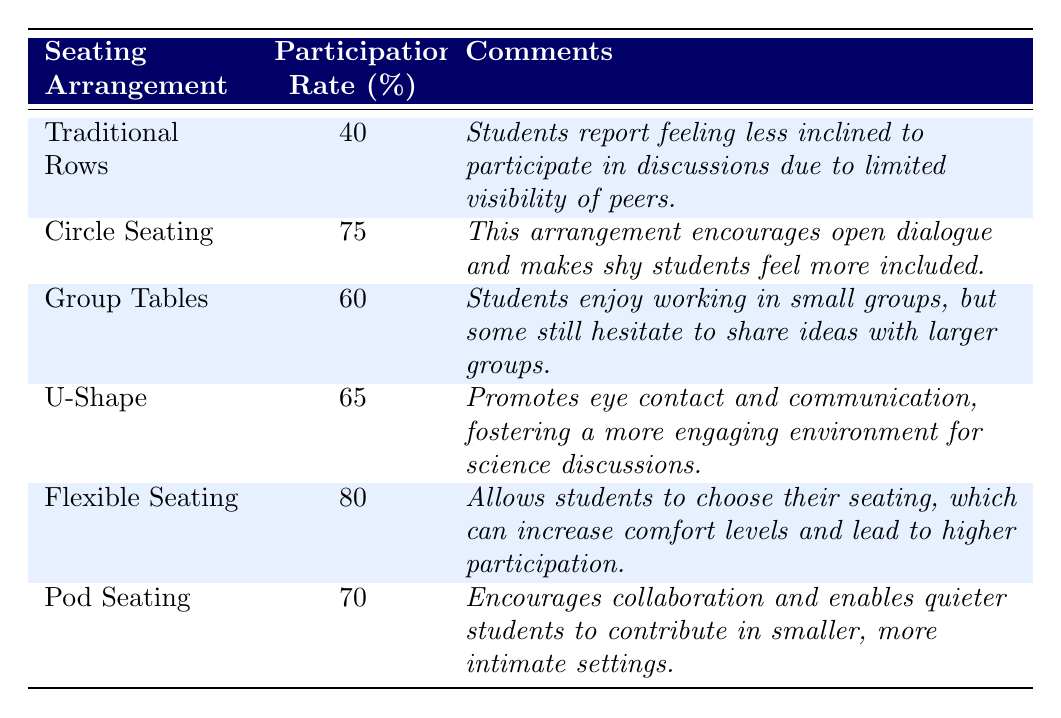What is the participation rate for Circle Seating? The table shows that the participation rate for Circle Seating is listed next to it under the Participation Rate column, which is 75%.
Answer: 75% What comments are associated with Pod Seating? The table displays the comments column next to Pod Seating, which states that it encourages collaboration and enables quieter students to contribute in smaller, more intimate settings.
Answer: Encourages collaboration and enables quieter students to contribute in smaller settings What is the average participation rate for all seating arrangements? To find the average, we sum all the participation rates: (40 + 75 + 60 + 65 + 80 + 70) = 420. We then divide by the number of arrangements, which is 6: 420 / 6 = 70.
Answer: 70 Which seating arrangement has the highest participation rate? By comparing the participation rates listed in the table, we can see that Flexible Seating has the highest rate of 80%.
Answer: Flexible Seating Is it true that Group Tables have a higher participation rate than Traditional Rows? The participation rate for Group Tables is 60%, while Traditional Rows is 40%. Since 60 is greater than 40, the statement is true.
Answer: Yes How much higher is the participation rate for Flexible Seating compared to Traditional Rows? The participation rate for Flexible Seating is 80% and that for Traditional Rows is 40%. To find the difference, we subtract: 80 - 40 = 40.
Answer: 40 Could a seating arrangement that encourages eye contact potentially increase participation? The table notes that the U-Shape arrangement promotes eye contact and communication, fostering a more engaging environment, implying it could indeed increase participation.
Answer: Yes Which seating arrangement's comments suggest it helps shy students? The comments for Circle Seating explicitly mention that it encourages open dialogue and makes shy students feel more included, indicating it helps them.
Answer: Circle Seating What is the percentage difference in participation rates between Flexible Seating and Group Tables? The participation rate for Flexible Seating is 80%, and for Group Tables, it is 60%. The difference is 80 - 60 = 20. To find the percentage difference relative to Group Tables: (20 / 60) * 100 = 33.33%.
Answer: 33.33% In what arrangement do students reportedly enjoy working in small groups? The comments for Group Tables indicate that students enjoy working in small groups, as mentioned explicitly in the comments section.
Answer: Group Tables 